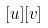Convert formula to latex. <formula><loc_0><loc_0><loc_500><loc_500>[ u ] [ v ]</formula> 